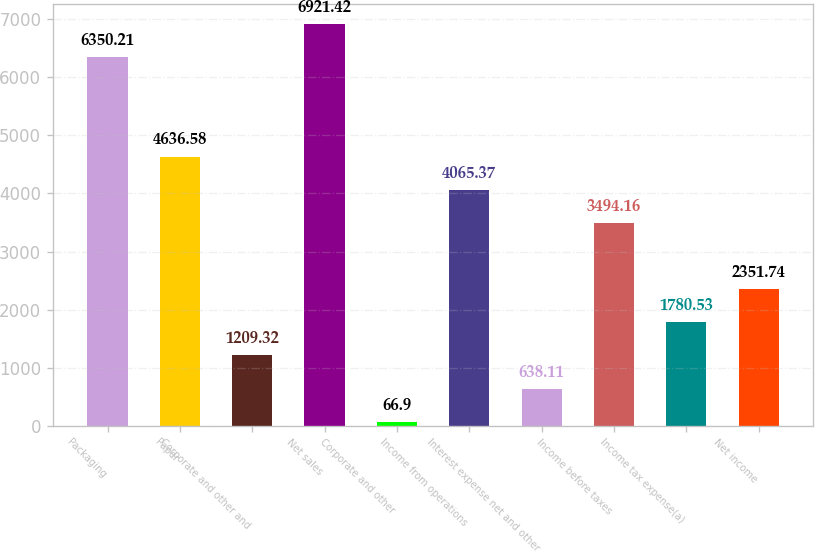Convert chart to OTSL. <chart><loc_0><loc_0><loc_500><loc_500><bar_chart><fcel>Packaging<fcel>Paper<fcel>Corporate and other and<fcel>Net sales<fcel>Corporate and other<fcel>Income from operations<fcel>Interest expense net and other<fcel>Income before taxes<fcel>Income tax expense(a)<fcel>Net income<nl><fcel>6350.21<fcel>4636.58<fcel>1209.32<fcel>6921.42<fcel>66.9<fcel>4065.37<fcel>638.11<fcel>3494.16<fcel>1780.53<fcel>2351.74<nl></chart> 